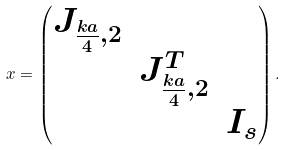Convert formula to latex. <formula><loc_0><loc_0><loc_500><loc_500>x = \begin{pmatrix} J _ { \frac { k a } { 4 } , 2 } \\ & J _ { \frac { k a } { 4 } , 2 } ^ { T } \\ & & I _ { s } \end{pmatrix} .</formula> 